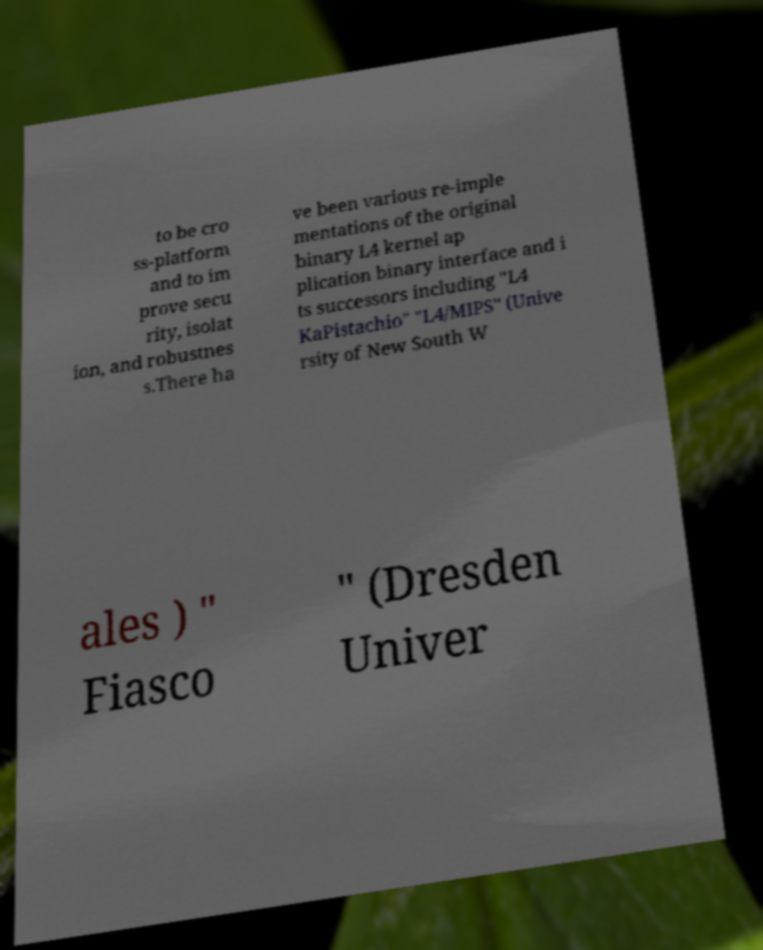Please identify and transcribe the text found in this image. to be cro ss-platform and to im prove secu rity, isolat ion, and robustnes s.There ha ve been various re-imple mentations of the original binary L4 kernel ap plication binary interface and i ts successors including "L4 KaPistachio" "L4/MIPS" (Unive rsity of New South W ales ) " Fiasco " (Dresden Univer 